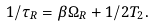Convert formula to latex. <formula><loc_0><loc_0><loc_500><loc_500>1 / \tau _ { R } = \beta \Omega _ { R } + 1 / 2 T _ { 2 } .</formula> 